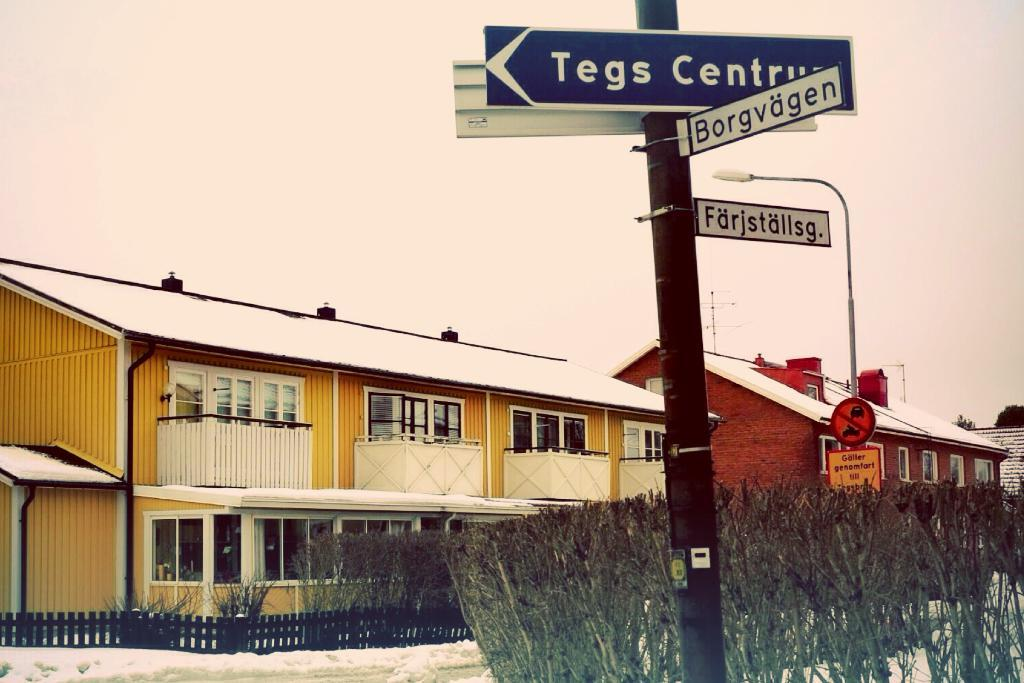What is the main object in the center of the image? There is a sign board in the center of the image. What can be seen in the background of the image? There are plants, buildings, a street light, and the sky visible in the background of the image. How long does the minister take to walk past the yak in the image? There is no minister or yak present in the image. What is the time duration of the minute shown in the image? There is no time duration or minute shown in the image. 